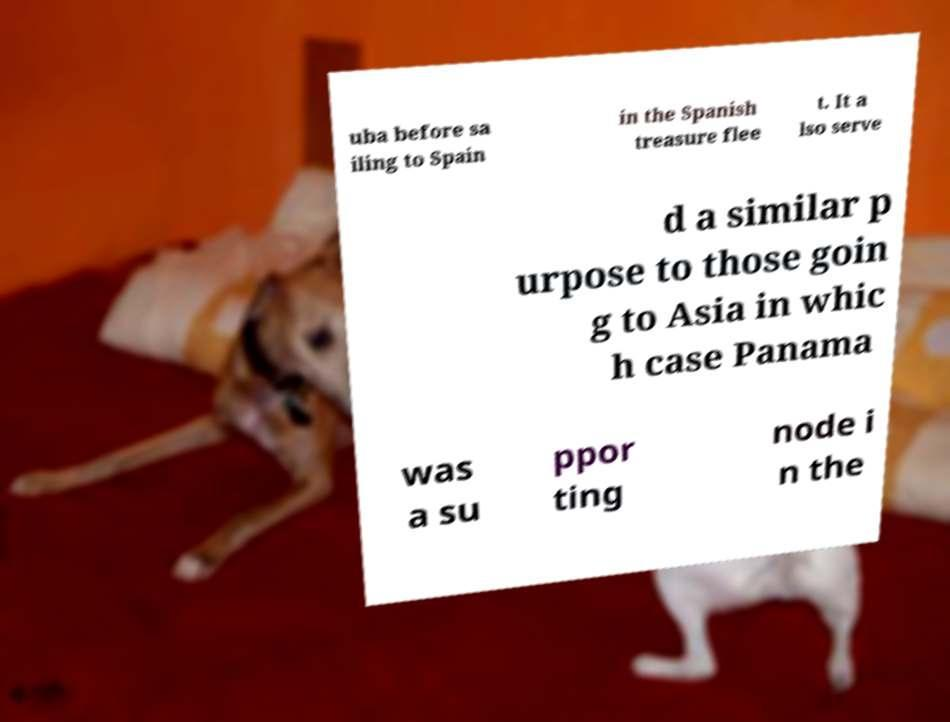Can you read and provide the text displayed in the image?This photo seems to have some interesting text. Can you extract and type it out for me? uba before sa iling to Spain in the Spanish treasure flee t. It a lso serve d a similar p urpose to those goin g to Asia in whic h case Panama was a su ppor ting node i n the 